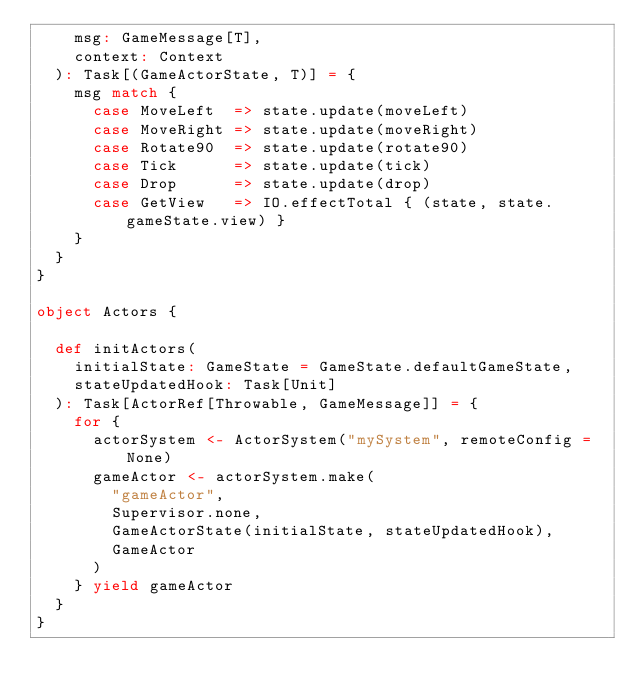Convert code to text. <code><loc_0><loc_0><loc_500><loc_500><_Scala_>    msg: GameMessage[T],
    context: Context
  ): Task[(GameActorState, T)] = {
    msg match {
      case MoveLeft  => state.update(moveLeft)
      case MoveRight => state.update(moveRight)
      case Rotate90  => state.update(rotate90)
      case Tick      => state.update(tick)
      case Drop      => state.update(drop)
      case GetView   => IO.effectTotal { (state, state.gameState.view) }
    }
  }
}

object Actors {

  def initActors(
    initialState: GameState = GameState.defaultGameState,
    stateUpdatedHook: Task[Unit]
  ): Task[ActorRef[Throwable, GameMessage]] = {
    for {
      actorSystem <- ActorSystem("mySystem", remoteConfig = None)
      gameActor <- actorSystem.make(
        "gameActor",
        Supervisor.none,
        GameActorState(initialState, stateUpdatedHook),
        GameActor
      )
    } yield gameActor
  }
}
</code> 